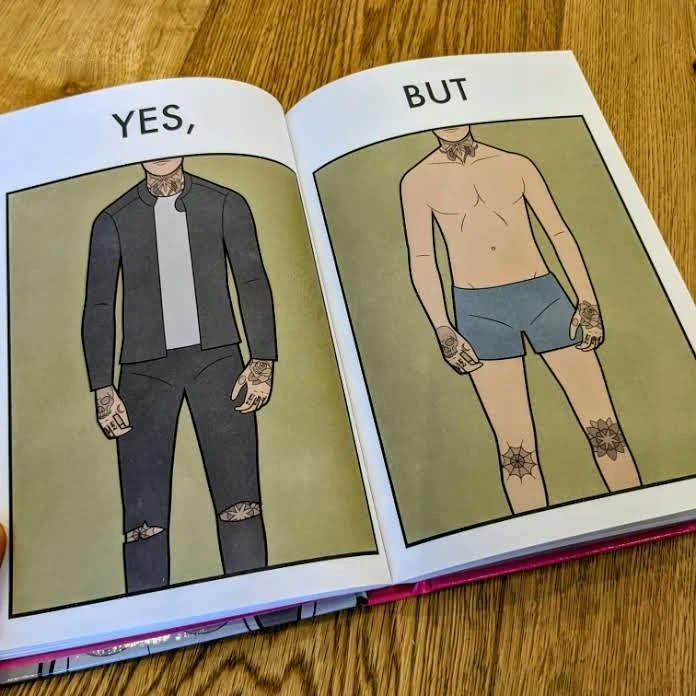Describe the content of this image. The image is funny, as the person has made tattoos at places that are visible when wearing clothes, but look very awkward otherwise. 